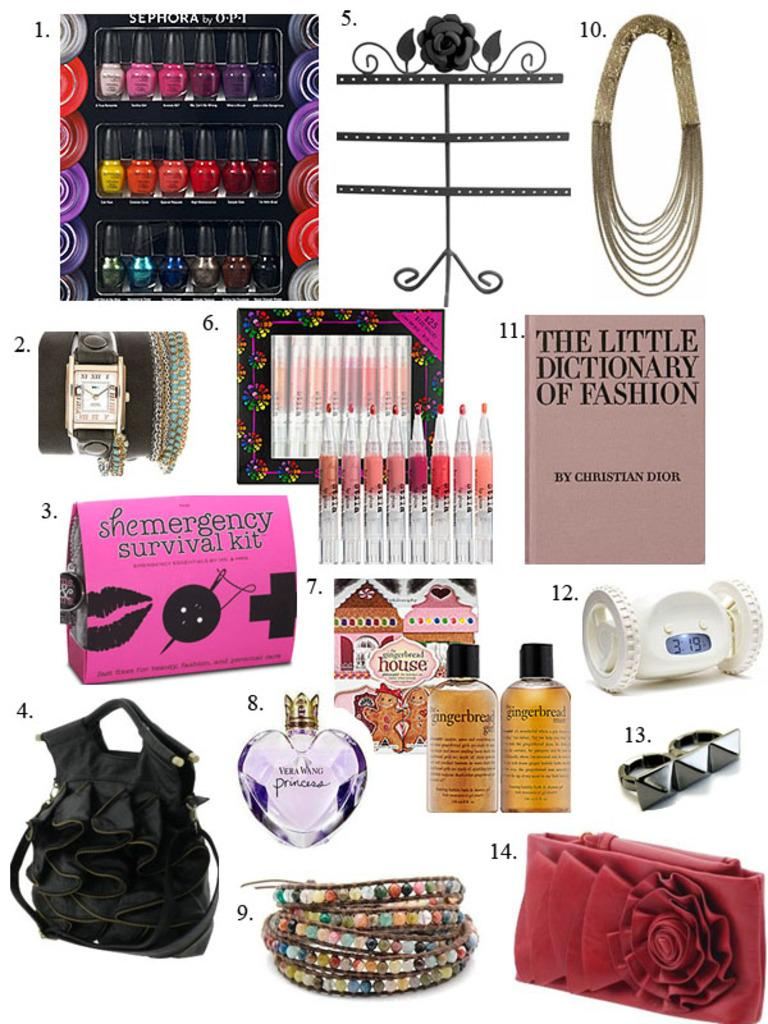<image>
Write a terse but informative summary of the picture. number 11 of the collection is a book named the little dictionary of fashion 